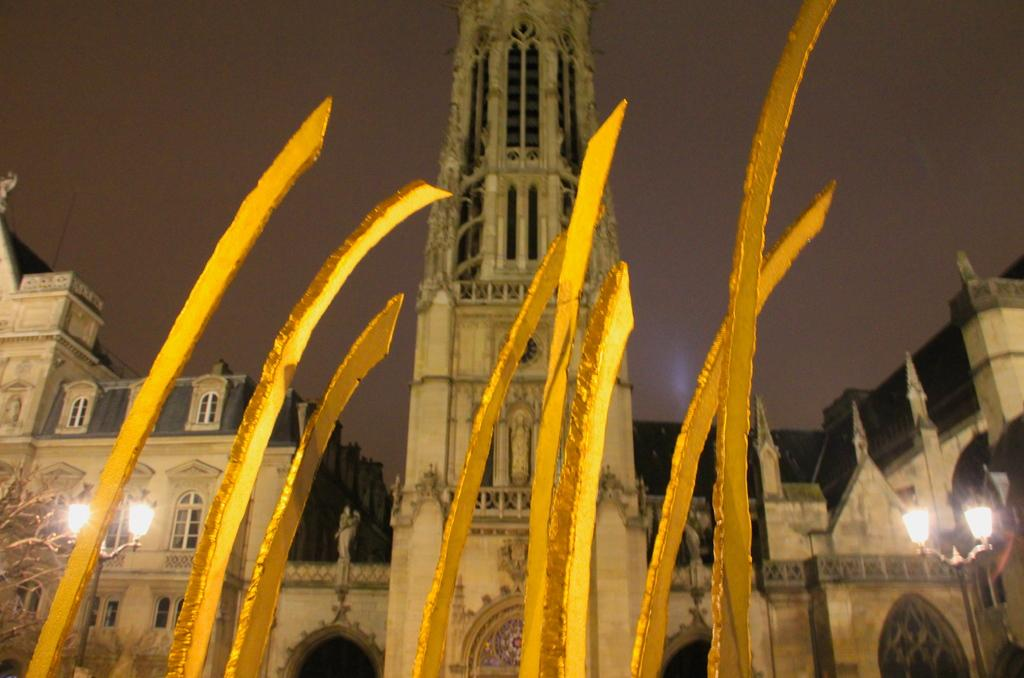What type of structures can be seen in the image? There are buildings and a tower in the image. What are the light sources in the image? Light poles are visible in the image. What type of vegetation is present in the image? There is a tree in the image. What is visible in the background of the image? The sky is visible in the image. What color objects can be seen in the image? There are yellow color objects in the image. What type of string is being used to hold up the buildings in the image? There is no string visible in the image, and the buildings are not being held up by any visible means. 